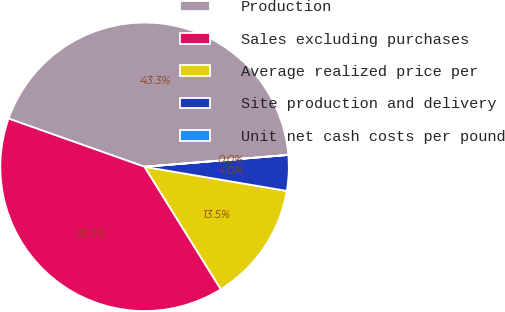Convert chart. <chart><loc_0><loc_0><loc_500><loc_500><pie_chart><fcel>Production<fcel>Sales excluding purchases<fcel>Average realized price per<fcel>Site production and delivery<fcel>Unit net cash costs per pound<nl><fcel>43.26%<fcel>39.29%<fcel>13.46%<fcel>3.98%<fcel>0.01%<nl></chart> 